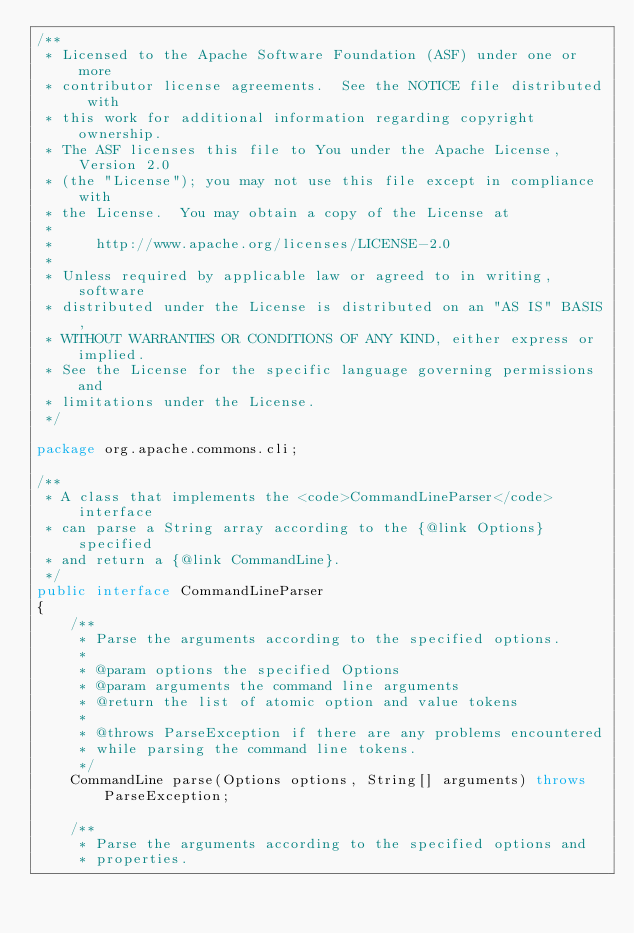Convert code to text. <code><loc_0><loc_0><loc_500><loc_500><_Java_>/**
 * Licensed to the Apache Software Foundation (ASF) under one or more
 * contributor license agreements.  See the NOTICE file distributed with
 * this work for additional information regarding copyright ownership.
 * The ASF licenses this file to You under the Apache License, Version 2.0
 * (the "License"); you may not use this file except in compliance with
 * the License.  You may obtain a copy of the License at
 *
 *     http://www.apache.org/licenses/LICENSE-2.0
 *
 * Unless required by applicable law or agreed to in writing, software
 * distributed under the License is distributed on an "AS IS" BASIS,
 * WITHOUT WARRANTIES OR CONDITIONS OF ANY KIND, either express or implied.
 * See the License for the specific language governing permissions and
 * limitations under the License.
 */

package org.apache.commons.cli;

/**
 * A class that implements the <code>CommandLineParser</code> interface
 * can parse a String array according to the {@link Options} specified
 * and return a {@link CommandLine}.
 */
public interface CommandLineParser
{
    /**
     * Parse the arguments according to the specified options.
     *
     * @param options the specified Options
     * @param arguments the command line arguments
     * @return the list of atomic option and value tokens
     *
     * @throws ParseException if there are any problems encountered
     * while parsing the command line tokens.
     */
    CommandLine parse(Options options, String[] arguments) throws ParseException;

    /**
     * Parse the arguments according to the specified options and
     * properties.</code> 